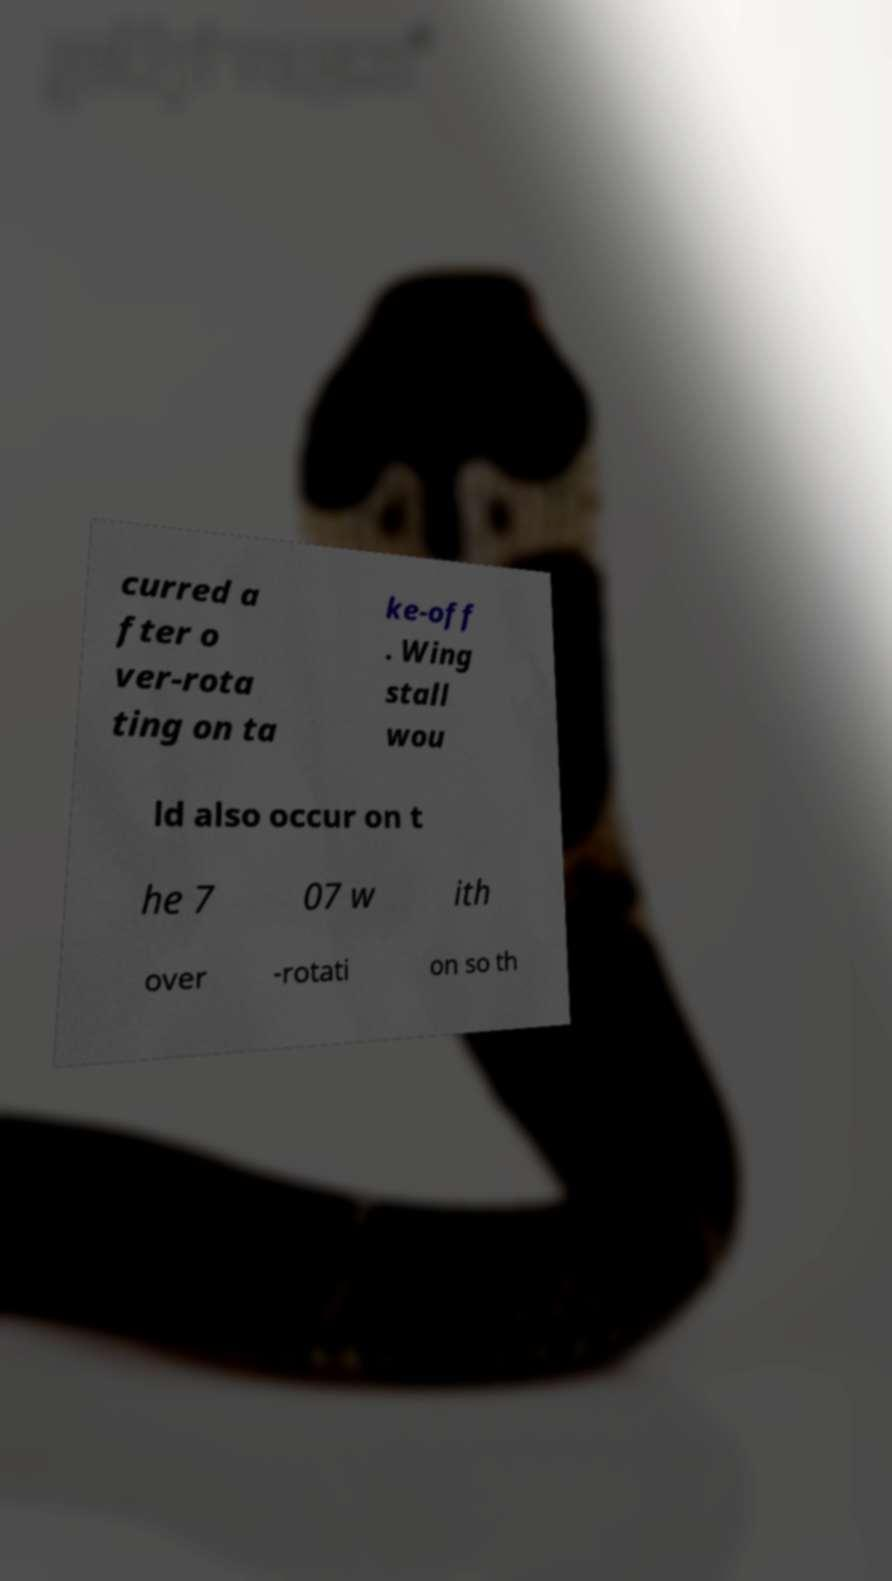Can you accurately transcribe the text from the provided image for me? curred a fter o ver-rota ting on ta ke-off . Wing stall wou ld also occur on t he 7 07 w ith over -rotati on so th 